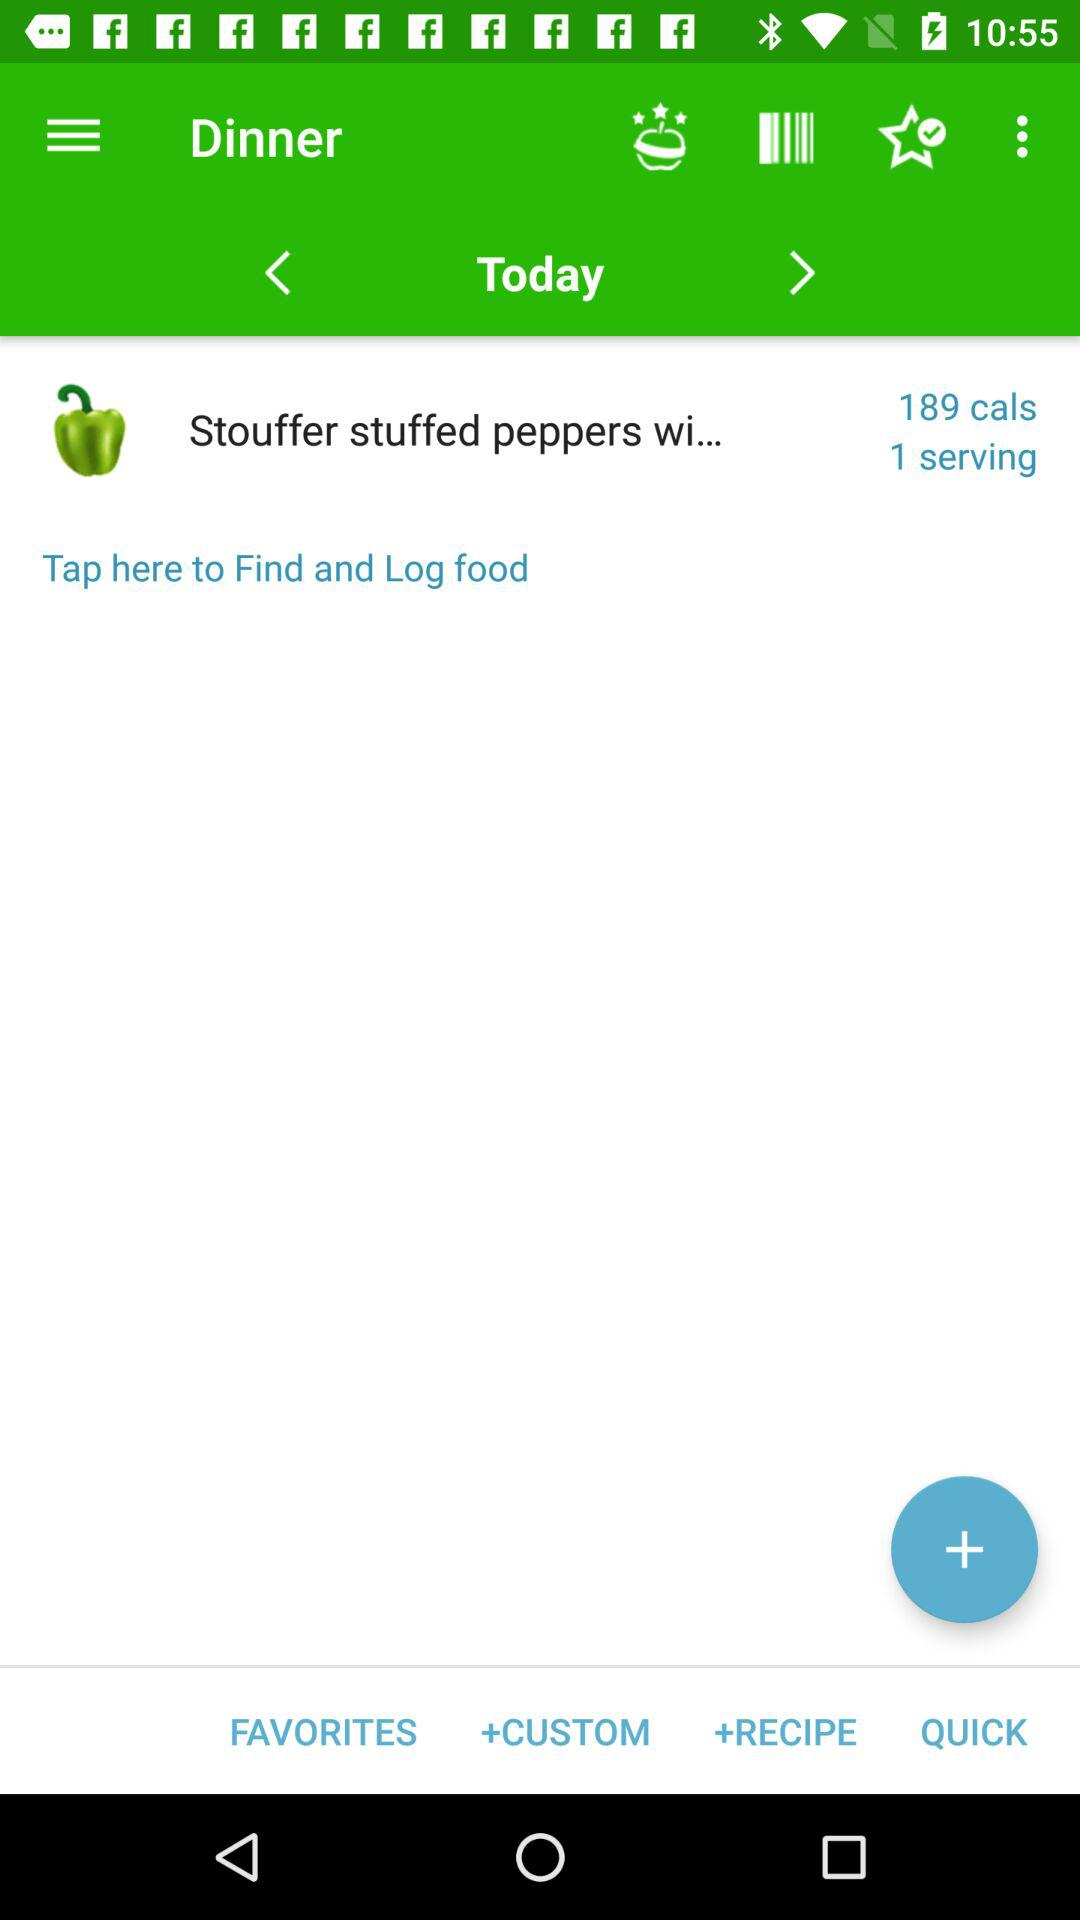How many calories are there in "Stouffer stuffed peppers wi..."? There are 189 calories in "Stouffer stuffed peppers wi...". 